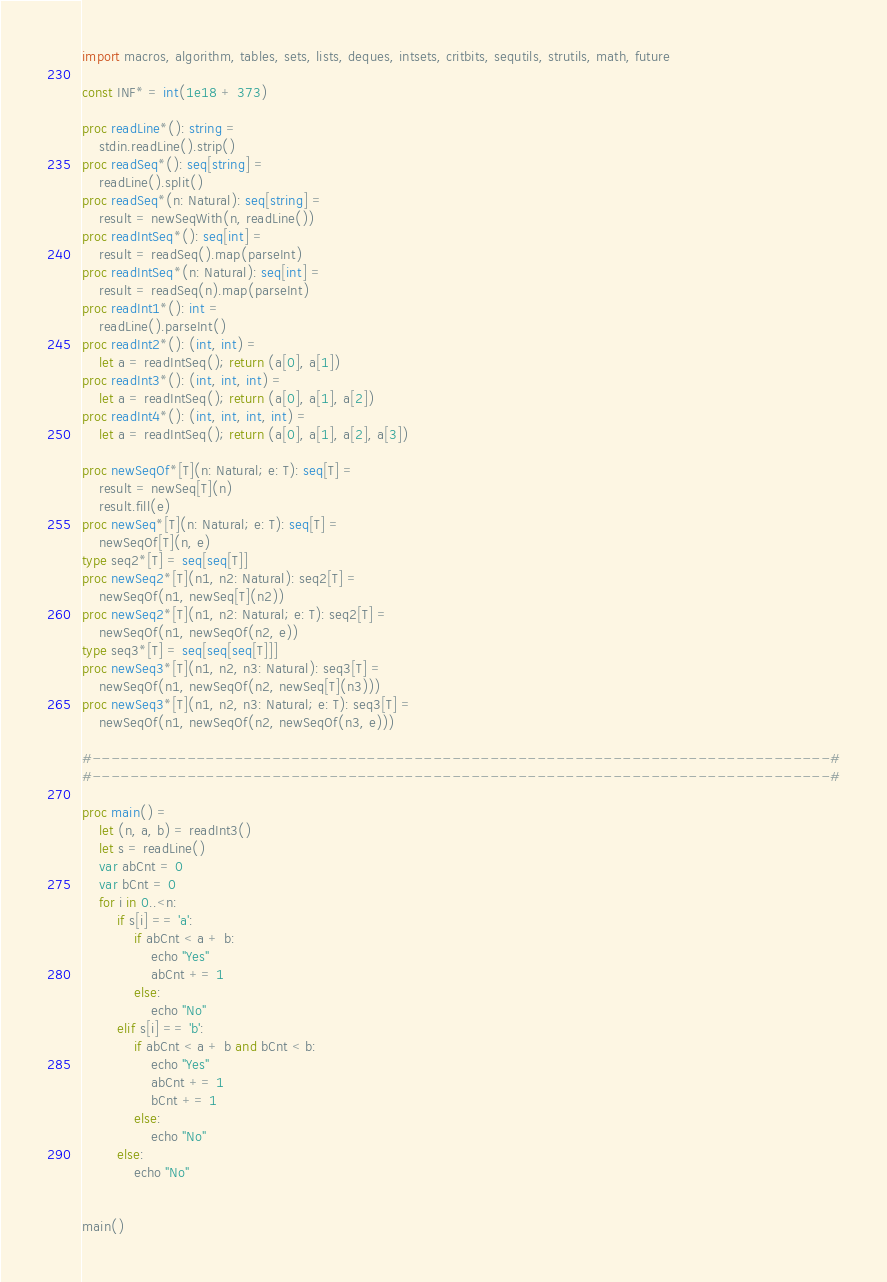Convert code to text. <code><loc_0><loc_0><loc_500><loc_500><_Nim_>import macros, algorithm, tables, sets, lists, deques, intsets, critbits, sequtils, strutils, math, future

const INF* = int(1e18 + 373)

proc readLine*(): string =
    stdin.readLine().strip()
proc readSeq*(): seq[string] =
    readLine().split()
proc readSeq*(n: Natural): seq[string] =
    result = newSeqWith(n, readLine())
proc readIntSeq*(): seq[int] =
    result = readSeq().map(parseInt)
proc readIntSeq*(n: Natural): seq[int] =
    result = readSeq(n).map(parseInt)
proc readInt1*(): int =
    readLine().parseInt()
proc readInt2*(): (int, int) =
    let a = readIntSeq(); return (a[0], a[1])
proc readInt3*(): (int, int, int) =
    let a = readIntSeq(); return (a[0], a[1], a[2])
proc readInt4*(): (int, int, int, int) =
    let a = readIntSeq(); return (a[0], a[1], a[2], a[3])

proc newSeqOf*[T](n: Natural; e: T): seq[T] =
    result = newSeq[T](n)
    result.fill(e)
proc newSeq*[T](n: Natural; e: T): seq[T] =
    newSeqOf[T](n, e)
type seq2*[T] = seq[seq[T]]
proc newSeq2*[T](n1, n2: Natural): seq2[T] =
    newSeqOf(n1, newSeq[T](n2))
proc newSeq2*[T](n1, n2: Natural; e: T): seq2[T] =
    newSeqOf(n1, newSeqOf(n2, e))
type seq3*[T] = seq[seq[seq[T]]]
proc newSeq3*[T](n1, n2, n3: Natural): seq3[T] =
    newSeqOf(n1, newSeqOf(n2, newSeq[T](n3)))
proc newSeq3*[T](n1, n2, n3: Natural; e: T): seq3[T] =
    newSeqOf(n1, newSeqOf(n2, newSeqOf(n3, e)))

#------------------------------------------------------------------------------#
#------------------------------------------------------------------------------#

proc main() =
    let (n, a, b) = readInt3()
    let s = readLine()
    var abCnt = 0
    var bCnt = 0
    for i in 0..<n:
        if s[i] == 'a':
            if abCnt < a + b:
                echo "Yes"
                abCnt += 1
            else:
                echo "No"
        elif s[i] == 'b':
            if abCnt < a + b and bCnt < b:
                echo "Yes"
                abCnt += 1
                bCnt += 1
            else:
                echo "No"
        else:
            echo "No"


main()
</code> 